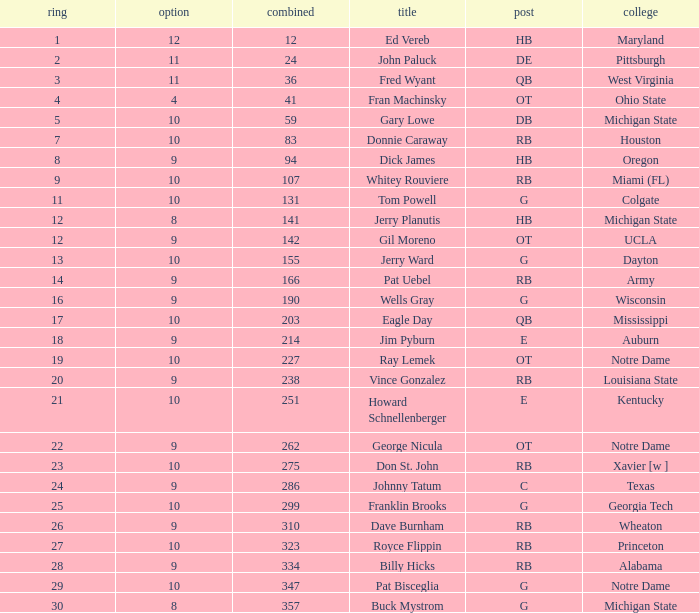What is the average number of rounds for billy hicks who had an overall pick number bigger than 310? 28.0. 